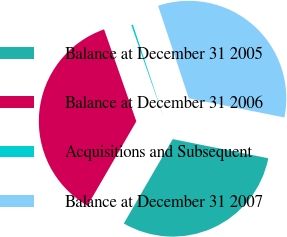Convert chart to OTSL. <chart><loc_0><loc_0><loc_500><loc_500><pie_chart><fcel>Balance at December 31 2005<fcel>Balance at December 31 2006<fcel>Acquisitions and Subsequent<fcel>Balance at December 31 2007<nl><fcel>30.21%<fcel>36.27%<fcel>0.27%<fcel>33.24%<nl></chart> 